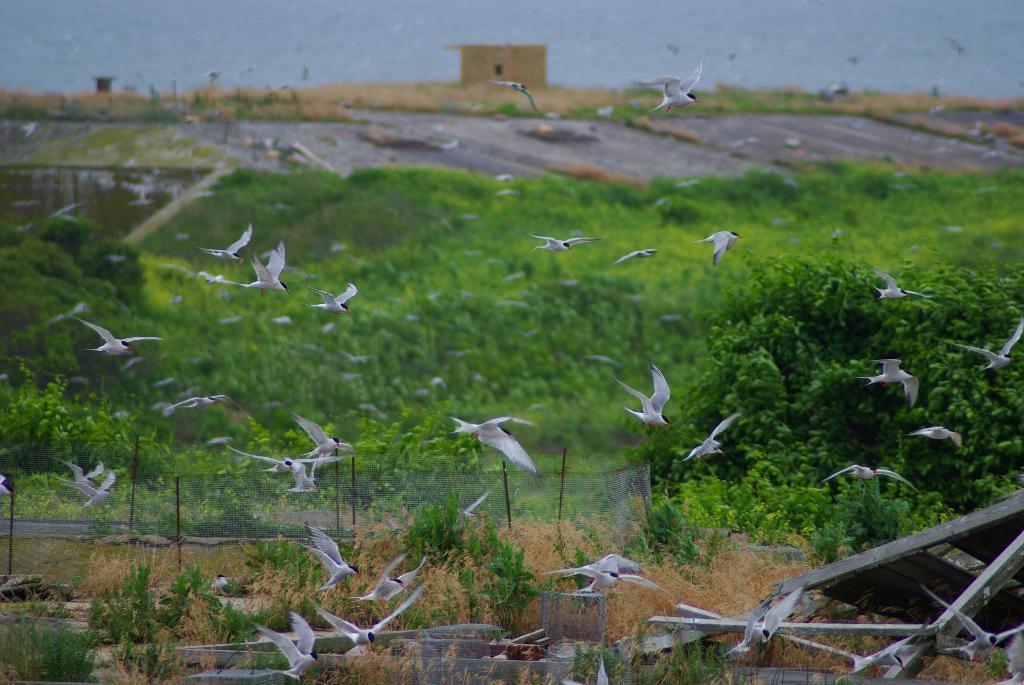Could you give a brief overview of what you see in this image? In this image we can see many birds flying. In the background there are trees, plants, fencing, shed and sky. 